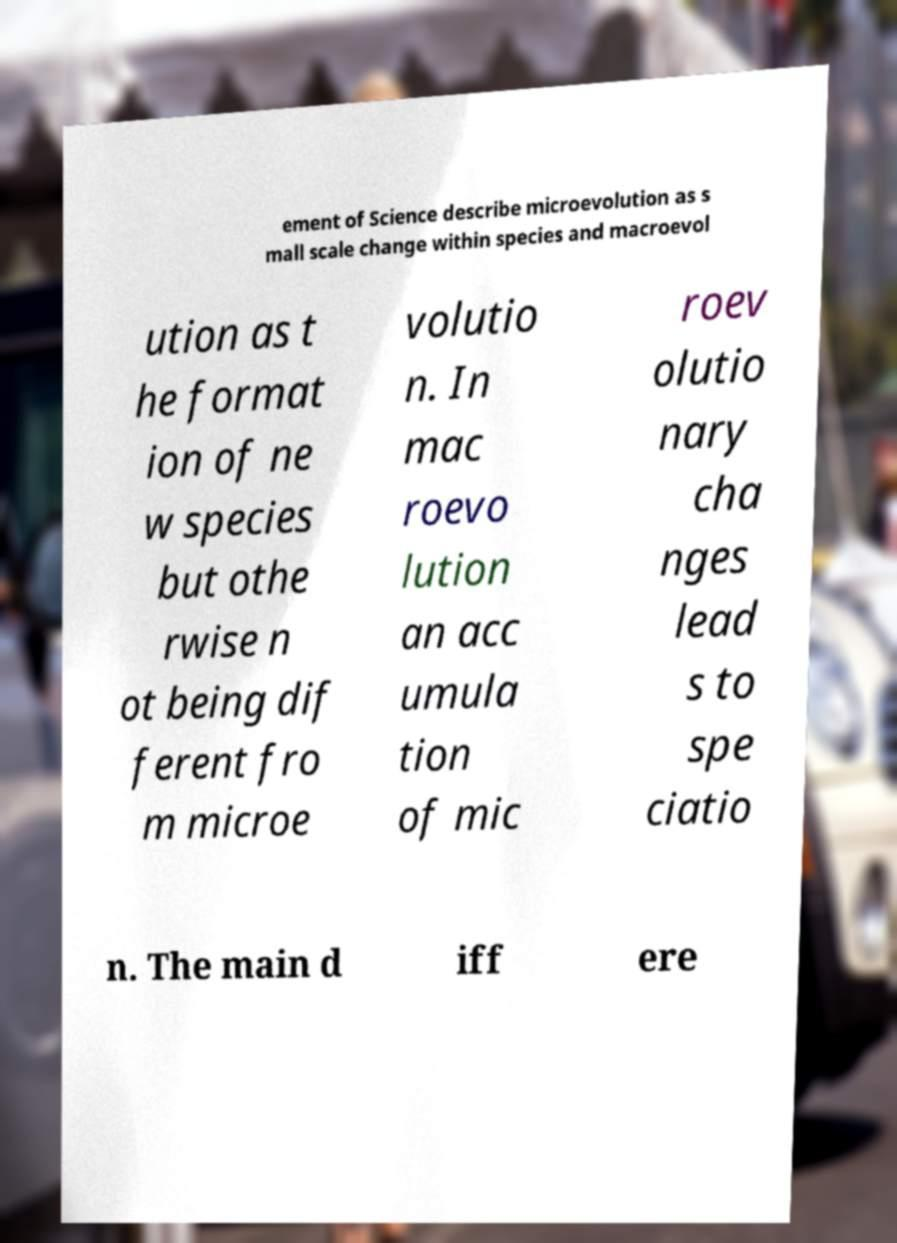Could you extract and type out the text from this image? ement of Science describe microevolution as s mall scale change within species and macroevol ution as t he format ion of ne w species but othe rwise n ot being dif ferent fro m microe volutio n. In mac roevo lution an acc umula tion of mic roev olutio nary cha nges lead s to spe ciatio n. The main d iff ere 